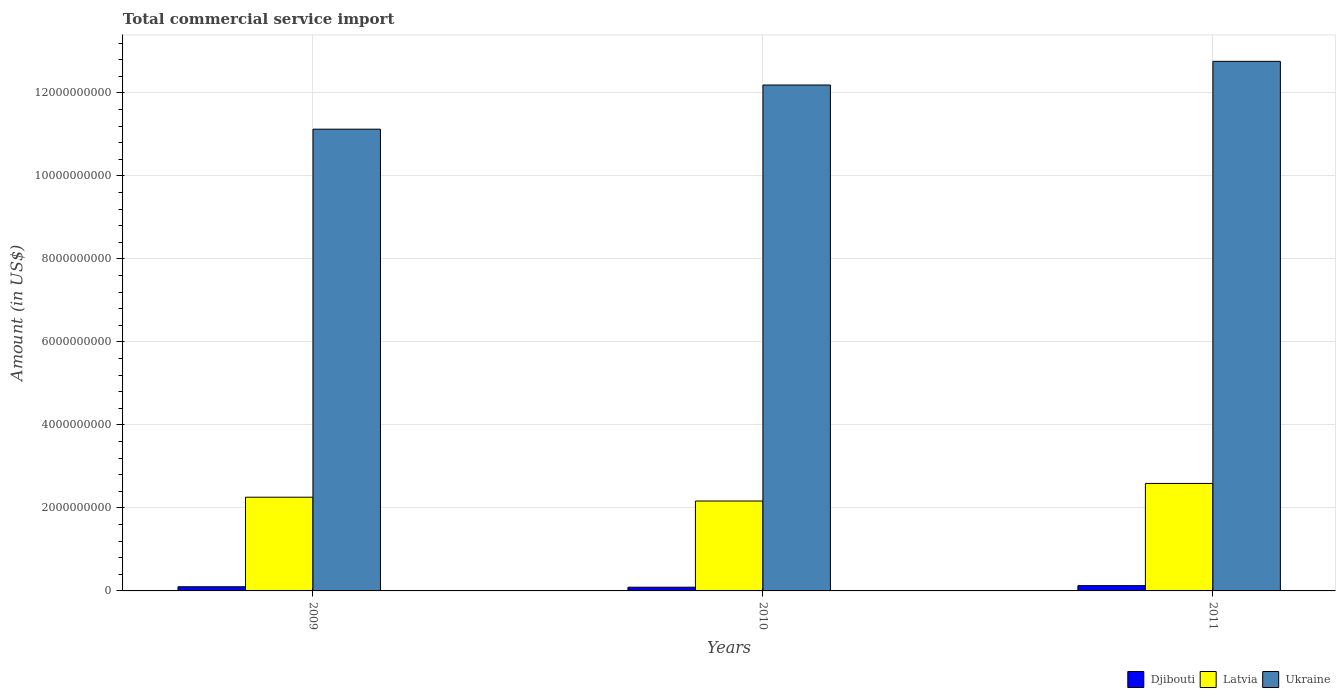How many different coloured bars are there?
Ensure brevity in your answer.  3. How many bars are there on the 2nd tick from the left?
Offer a very short reply. 3. In how many cases, is the number of bars for a given year not equal to the number of legend labels?
Give a very brief answer. 0. What is the total commercial service import in Djibouti in 2009?
Keep it short and to the point. 1.00e+08. Across all years, what is the maximum total commercial service import in Djibouti?
Give a very brief answer. 1.27e+08. Across all years, what is the minimum total commercial service import in Ukraine?
Offer a terse response. 1.11e+1. In which year was the total commercial service import in Djibouti maximum?
Give a very brief answer. 2011. In which year was the total commercial service import in Latvia minimum?
Your answer should be very brief. 2010. What is the total total commercial service import in Djibouti in the graph?
Your answer should be compact. 3.17e+08. What is the difference between the total commercial service import in Djibouti in 2010 and that in 2011?
Provide a short and direct response. -3.78e+07. What is the difference between the total commercial service import in Djibouti in 2011 and the total commercial service import in Ukraine in 2009?
Keep it short and to the point. -1.10e+1. What is the average total commercial service import in Djibouti per year?
Provide a succinct answer. 1.06e+08. In the year 2011, what is the difference between the total commercial service import in Ukraine and total commercial service import in Djibouti?
Your answer should be compact. 1.26e+1. What is the ratio of the total commercial service import in Latvia in 2009 to that in 2011?
Provide a succinct answer. 0.87. Is the total commercial service import in Ukraine in 2010 less than that in 2011?
Provide a succinct answer. Yes. What is the difference between the highest and the second highest total commercial service import in Ukraine?
Your response must be concise. 5.70e+08. What is the difference between the highest and the lowest total commercial service import in Ukraine?
Offer a terse response. 1.63e+09. Is the sum of the total commercial service import in Djibouti in 2010 and 2011 greater than the maximum total commercial service import in Ukraine across all years?
Offer a very short reply. No. What does the 3rd bar from the left in 2009 represents?
Ensure brevity in your answer.  Ukraine. What does the 1st bar from the right in 2009 represents?
Your response must be concise. Ukraine. Is it the case that in every year, the sum of the total commercial service import in Latvia and total commercial service import in Ukraine is greater than the total commercial service import in Djibouti?
Give a very brief answer. Yes. How many bars are there?
Keep it short and to the point. 9. Are all the bars in the graph horizontal?
Provide a short and direct response. No. How many years are there in the graph?
Your answer should be very brief. 3. Are the values on the major ticks of Y-axis written in scientific E-notation?
Provide a succinct answer. No. Where does the legend appear in the graph?
Ensure brevity in your answer.  Bottom right. How are the legend labels stacked?
Provide a succinct answer. Horizontal. What is the title of the graph?
Your answer should be compact. Total commercial service import. What is the Amount (in US$) of Djibouti in 2009?
Ensure brevity in your answer.  1.00e+08. What is the Amount (in US$) of Latvia in 2009?
Give a very brief answer. 2.26e+09. What is the Amount (in US$) of Ukraine in 2009?
Provide a short and direct response. 1.11e+1. What is the Amount (in US$) in Djibouti in 2010?
Offer a very short reply. 8.92e+07. What is the Amount (in US$) of Latvia in 2010?
Keep it short and to the point. 2.17e+09. What is the Amount (in US$) of Ukraine in 2010?
Your answer should be compact. 1.22e+1. What is the Amount (in US$) in Djibouti in 2011?
Make the answer very short. 1.27e+08. What is the Amount (in US$) in Latvia in 2011?
Offer a very short reply. 2.59e+09. What is the Amount (in US$) of Ukraine in 2011?
Offer a terse response. 1.28e+1. Across all years, what is the maximum Amount (in US$) of Djibouti?
Your response must be concise. 1.27e+08. Across all years, what is the maximum Amount (in US$) of Latvia?
Keep it short and to the point. 2.59e+09. Across all years, what is the maximum Amount (in US$) in Ukraine?
Your answer should be very brief. 1.28e+1. Across all years, what is the minimum Amount (in US$) of Djibouti?
Ensure brevity in your answer.  8.92e+07. Across all years, what is the minimum Amount (in US$) in Latvia?
Provide a succinct answer. 2.17e+09. Across all years, what is the minimum Amount (in US$) in Ukraine?
Offer a terse response. 1.11e+1. What is the total Amount (in US$) of Djibouti in the graph?
Your answer should be very brief. 3.17e+08. What is the total Amount (in US$) of Latvia in the graph?
Provide a succinct answer. 7.01e+09. What is the total Amount (in US$) in Ukraine in the graph?
Make the answer very short. 3.61e+1. What is the difference between the Amount (in US$) in Djibouti in 2009 and that in 2010?
Make the answer very short. 1.13e+07. What is the difference between the Amount (in US$) in Latvia in 2009 and that in 2010?
Your response must be concise. 9.19e+07. What is the difference between the Amount (in US$) of Ukraine in 2009 and that in 2010?
Ensure brevity in your answer.  -1.06e+09. What is the difference between the Amount (in US$) in Djibouti in 2009 and that in 2011?
Provide a short and direct response. -2.65e+07. What is the difference between the Amount (in US$) of Latvia in 2009 and that in 2011?
Your answer should be very brief. -3.32e+08. What is the difference between the Amount (in US$) in Ukraine in 2009 and that in 2011?
Ensure brevity in your answer.  -1.63e+09. What is the difference between the Amount (in US$) in Djibouti in 2010 and that in 2011?
Offer a very short reply. -3.78e+07. What is the difference between the Amount (in US$) in Latvia in 2010 and that in 2011?
Ensure brevity in your answer.  -4.24e+08. What is the difference between the Amount (in US$) of Ukraine in 2010 and that in 2011?
Keep it short and to the point. -5.70e+08. What is the difference between the Amount (in US$) of Djibouti in 2009 and the Amount (in US$) of Latvia in 2010?
Ensure brevity in your answer.  -2.07e+09. What is the difference between the Amount (in US$) of Djibouti in 2009 and the Amount (in US$) of Ukraine in 2010?
Offer a terse response. -1.21e+1. What is the difference between the Amount (in US$) of Latvia in 2009 and the Amount (in US$) of Ukraine in 2010?
Provide a short and direct response. -9.93e+09. What is the difference between the Amount (in US$) in Djibouti in 2009 and the Amount (in US$) in Latvia in 2011?
Your answer should be very brief. -2.49e+09. What is the difference between the Amount (in US$) in Djibouti in 2009 and the Amount (in US$) in Ukraine in 2011?
Keep it short and to the point. -1.27e+1. What is the difference between the Amount (in US$) in Latvia in 2009 and the Amount (in US$) in Ukraine in 2011?
Give a very brief answer. -1.05e+1. What is the difference between the Amount (in US$) in Djibouti in 2010 and the Amount (in US$) in Latvia in 2011?
Your response must be concise. -2.50e+09. What is the difference between the Amount (in US$) of Djibouti in 2010 and the Amount (in US$) of Ukraine in 2011?
Your answer should be very brief. -1.27e+1. What is the difference between the Amount (in US$) of Latvia in 2010 and the Amount (in US$) of Ukraine in 2011?
Offer a terse response. -1.06e+1. What is the average Amount (in US$) of Djibouti per year?
Offer a terse response. 1.06e+08. What is the average Amount (in US$) of Latvia per year?
Provide a succinct answer. 2.34e+09. What is the average Amount (in US$) in Ukraine per year?
Ensure brevity in your answer.  1.20e+1. In the year 2009, what is the difference between the Amount (in US$) in Djibouti and Amount (in US$) in Latvia?
Your response must be concise. -2.16e+09. In the year 2009, what is the difference between the Amount (in US$) in Djibouti and Amount (in US$) in Ukraine?
Give a very brief answer. -1.10e+1. In the year 2009, what is the difference between the Amount (in US$) of Latvia and Amount (in US$) of Ukraine?
Offer a terse response. -8.87e+09. In the year 2010, what is the difference between the Amount (in US$) of Djibouti and Amount (in US$) of Latvia?
Give a very brief answer. -2.08e+09. In the year 2010, what is the difference between the Amount (in US$) in Djibouti and Amount (in US$) in Ukraine?
Your answer should be very brief. -1.21e+1. In the year 2010, what is the difference between the Amount (in US$) in Latvia and Amount (in US$) in Ukraine?
Provide a succinct answer. -1.00e+1. In the year 2011, what is the difference between the Amount (in US$) of Djibouti and Amount (in US$) of Latvia?
Offer a terse response. -2.46e+09. In the year 2011, what is the difference between the Amount (in US$) of Djibouti and Amount (in US$) of Ukraine?
Provide a short and direct response. -1.26e+1. In the year 2011, what is the difference between the Amount (in US$) of Latvia and Amount (in US$) of Ukraine?
Your response must be concise. -1.02e+1. What is the ratio of the Amount (in US$) of Djibouti in 2009 to that in 2010?
Give a very brief answer. 1.13. What is the ratio of the Amount (in US$) of Latvia in 2009 to that in 2010?
Provide a succinct answer. 1.04. What is the ratio of the Amount (in US$) of Ukraine in 2009 to that in 2010?
Provide a short and direct response. 0.91. What is the ratio of the Amount (in US$) in Djibouti in 2009 to that in 2011?
Provide a short and direct response. 0.79. What is the ratio of the Amount (in US$) in Latvia in 2009 to that in 2011?
Keep it short and to the point. 0.87. What is the ratio of the Amount (in US$) in Ukraine in 2009 to that in 2011?
Keep it short and to the point. 0.87. What is the ratio of the Amount (in US$) in Djibouti in 2010 to that in 2011?
Give a very brief answer. 0.7. What is the ratio of the Amount (in US$) in Latvia in 2010 to that in 2011?
Give a very brief answer. 0.84. What is the ratio of the Amount (in US$) in Ukraine in 2010 to that in 2011?
Your answer should be very brief. 0.96. What is the difference between the highest and the second highest Amount (in US$) of Djibouti?
Offer a very short reply. 2.65e+07. What is the difference between the highest and the second highest Amount (in US$) in Latvia?
Your answer should be very brief. 3.32e+08. What is the difference between the highest and the second highest Amount (in US$) of Ukraine?
Keep it short and to the point. 5.70e+08. What is the difference between the highest and the lowest Amount (in US$) of Djibouti?
Provide a short and direct response. 3.78e+07. What is the difference between the highest and the lowest Amount (in US$) of Latvia?
Provide a short and direct response. 4.24e+08. What is the difference between the highest and the lowest Amount (in US$) of Ukraine?
Give a very brief answer. 1.63e+09. 